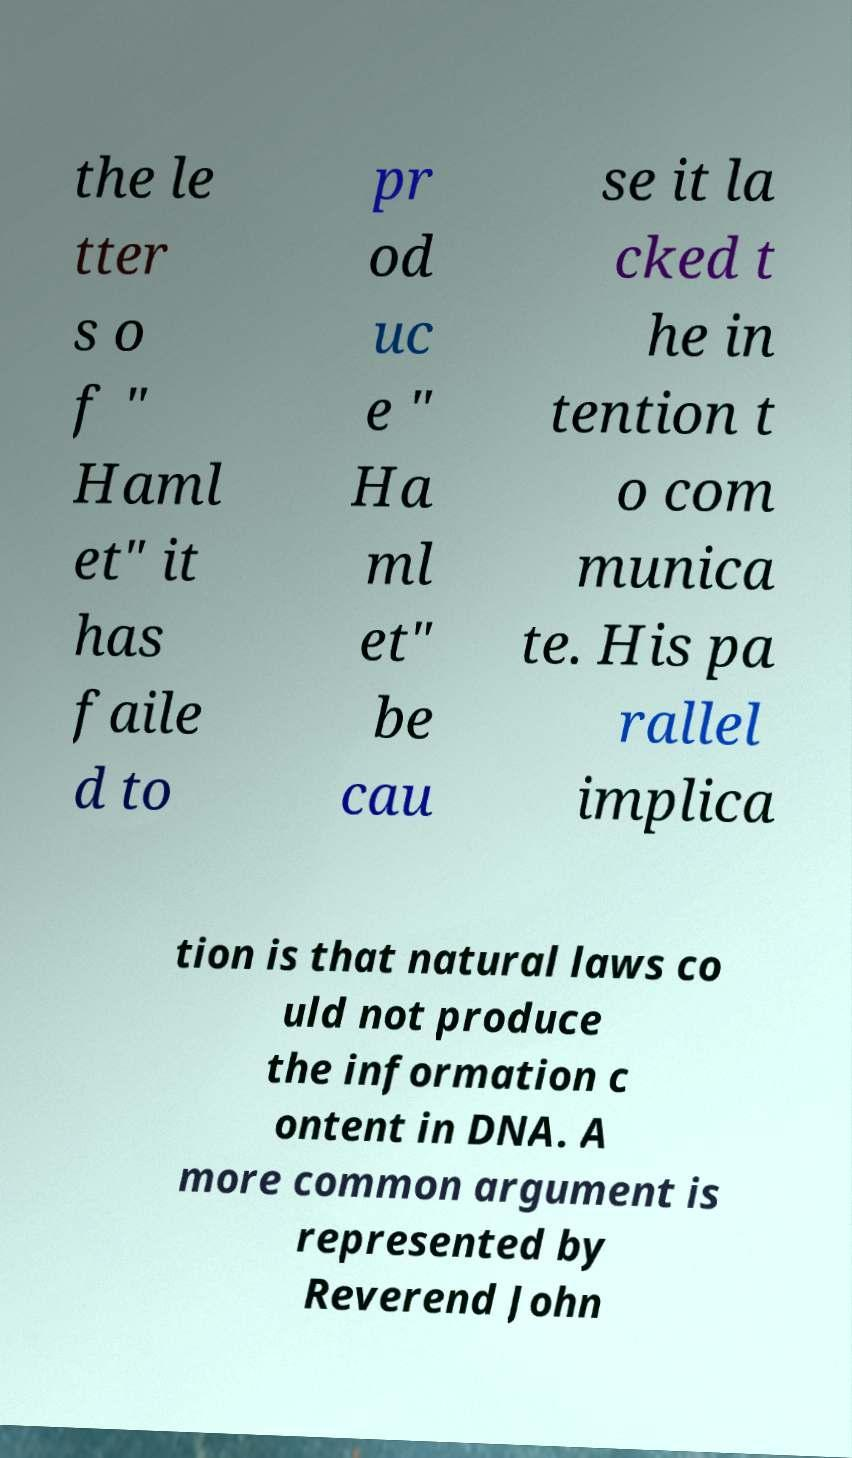Can you accurately transcribe the text from the provided image for me? the le tter s o f " Haml et" it has faile d to pr od uc e " Ha ml et" be cau se it la cked t he in tention t o com munica te. His pa rallel implica tion is that natural laws co uld not produce the information c ontent in DNA. A more common argument is represented by Reverend John 